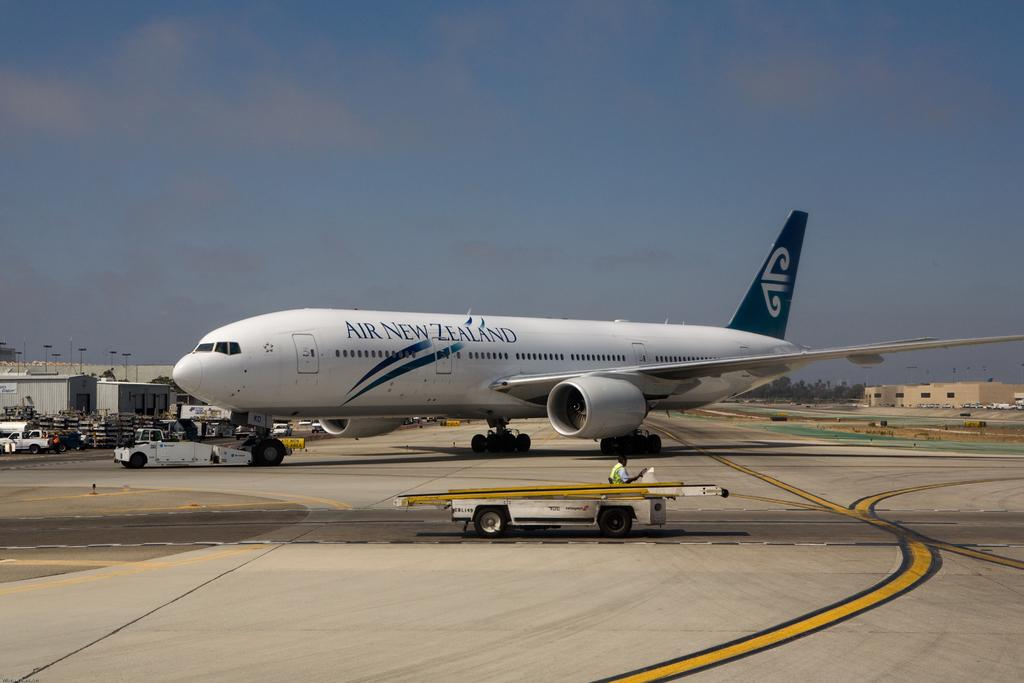What is the main subject of the image? The main subject of the image is an airplane. What is the color of the airplane? The airplane is white in color. What can be seen in the background of the image? The image contains a runway. How many apples can be seen on the airplane in the image? There are no apples present in the image; it features an airplane on a runway. Can you describe the picture hanging on the wall in the image? There is no picture hanging on the wall in the image; it only contains an airplane and a runway. 